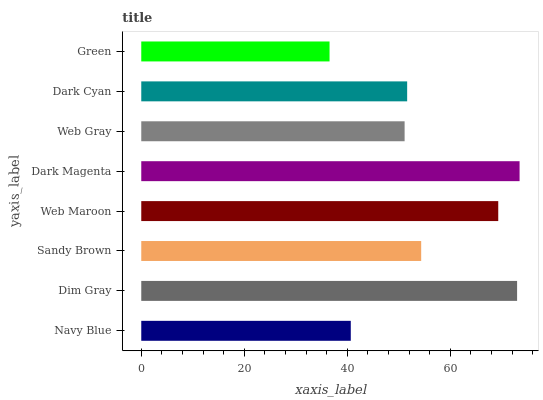Is Green the minimum?
Answer yes or no. Yes. Is Dark Magenta the maximum?
Answer yes or no. Yes. Is Dim Gray the minimum?
Answer yes or no. No. Is Dim Gray the maximum?
Answer yes or no. No. Is Dim Gray greater than Navy Blue?
Answer yes or no. Yes. Is Navy Blue less than Dim Gray?
Answer yes or no. Yes. Is Navy Blue greater than Dim Gray?
Answer yes or no. No. Is Dim Gray less than Navy Blue?
Answer yes or no. No. Is Sandy Brown the high median?
Answer yes or no. Yes. Is Dark Cyan the low median?
Answer yes or no. Yes. Is Dark Cyan the high median?
Answer yes or no. No. Is Web Gray the low median?
Answer yes or no. No. 